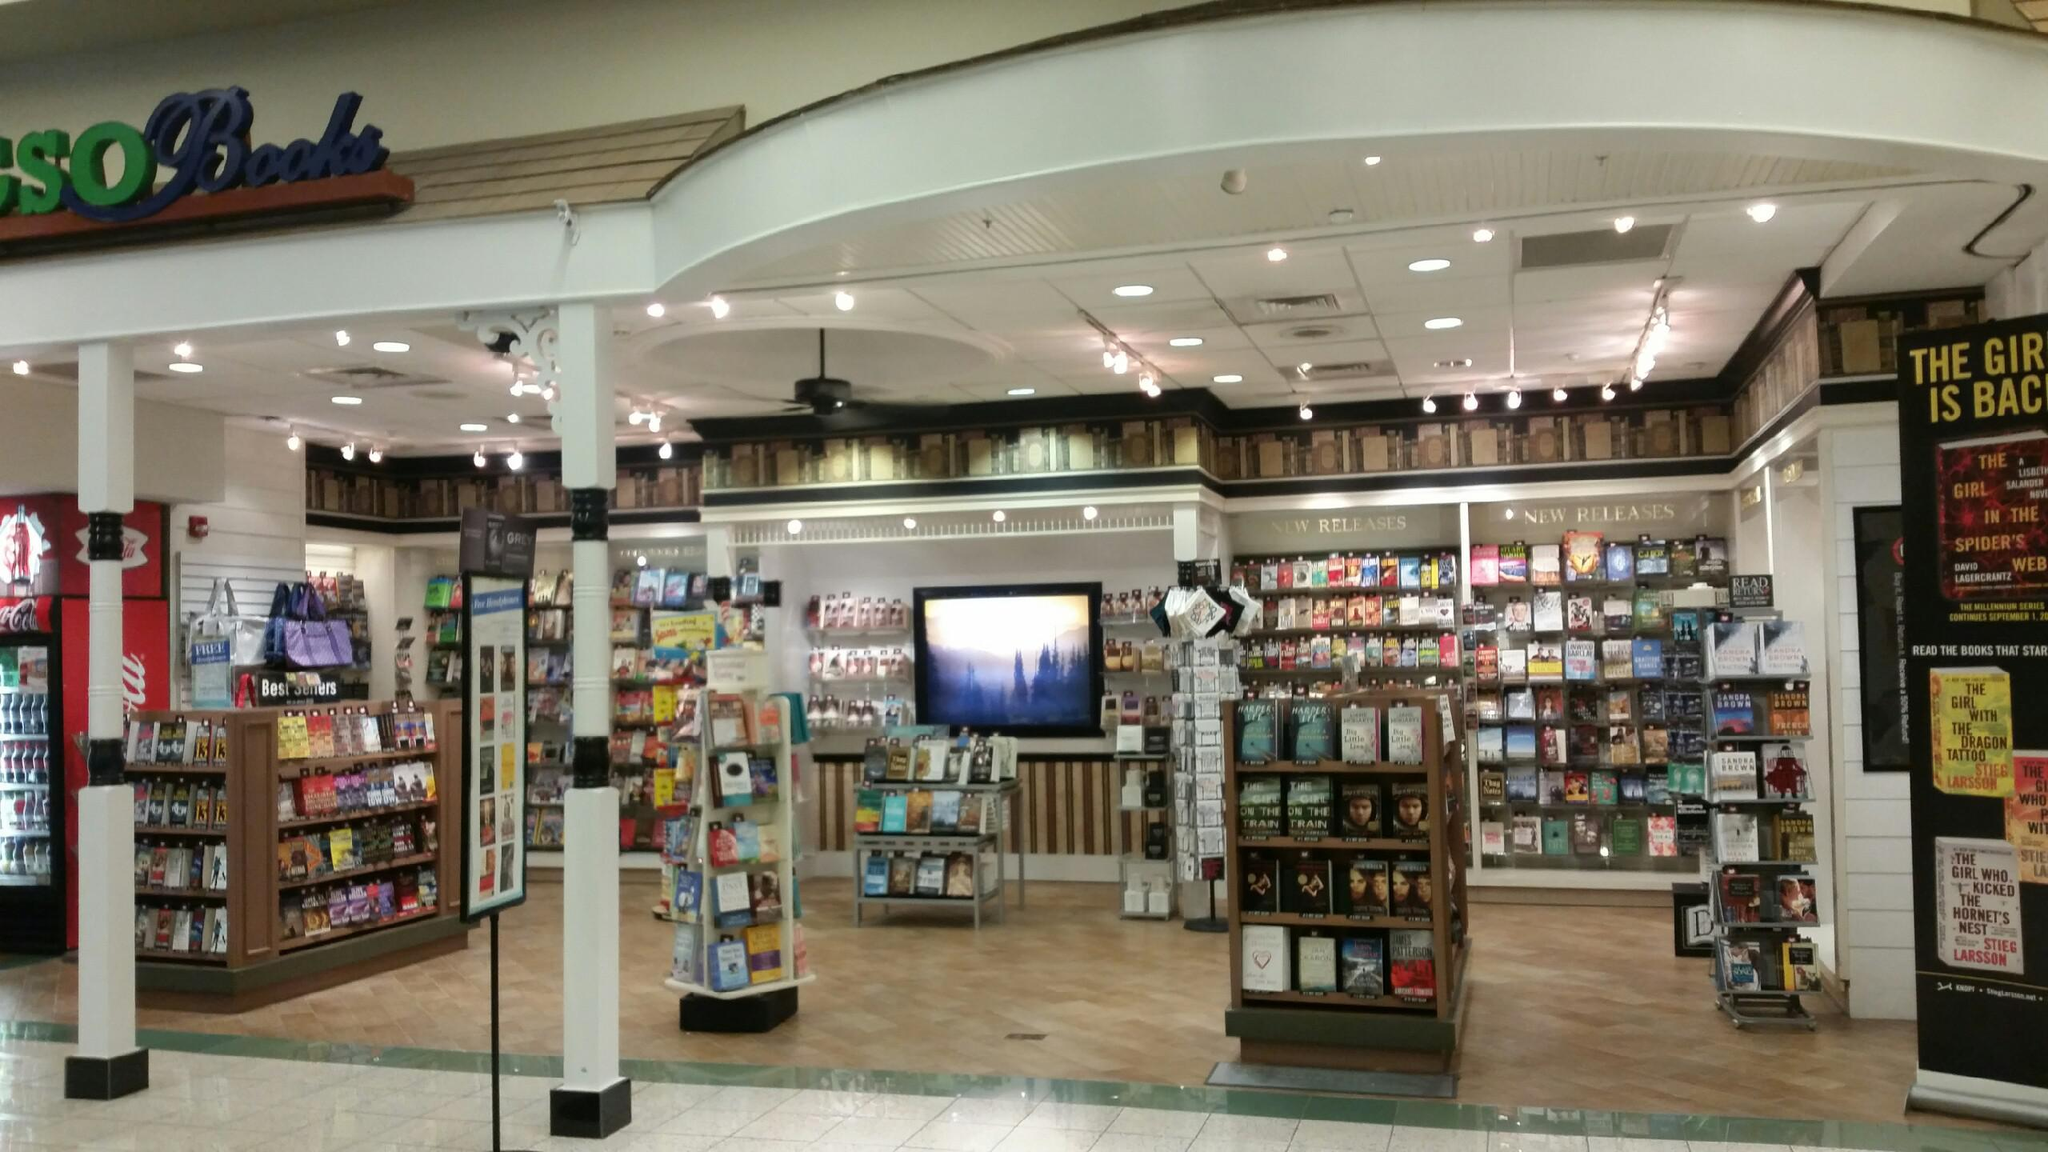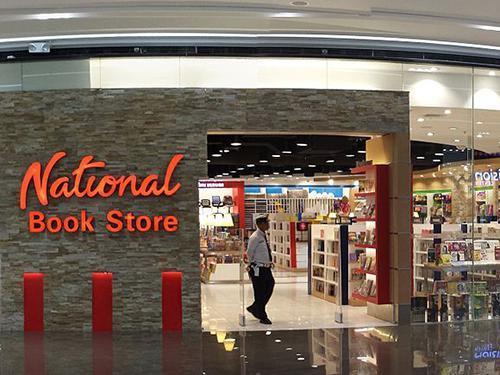The first image is the image on the left, the second image is the image on the right. Considering the images on both sides, is "There are at least two people in the image on the right." valid? Answer yes or no. No. 